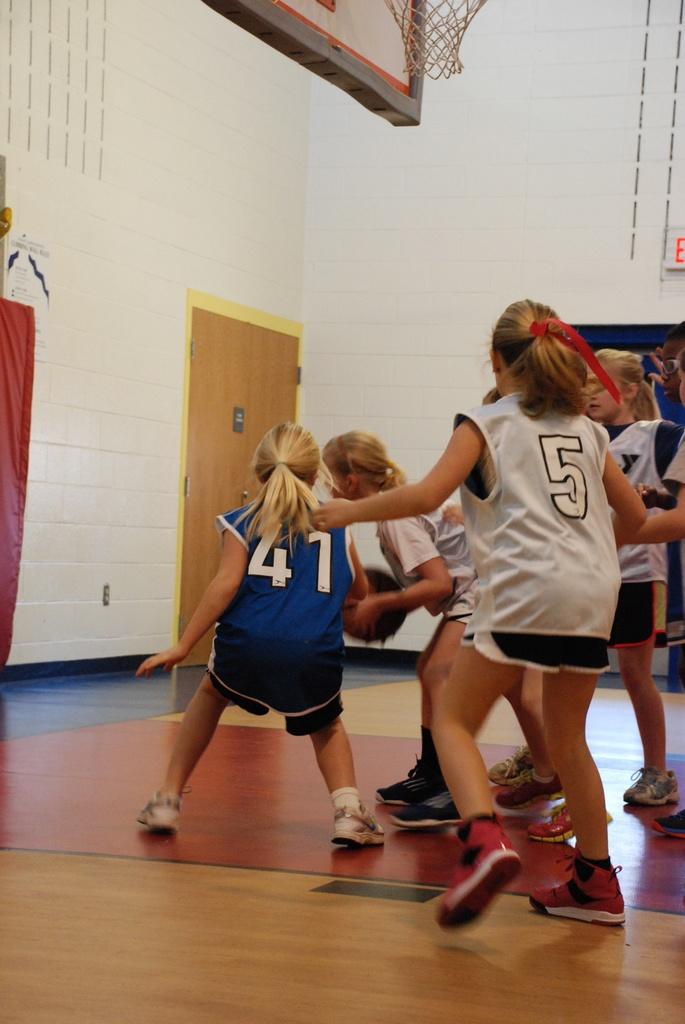What number is the only blue player?
Make the answer very short. 41. What number is the player in the white shirt?
Keep it short and to the point. 5. 